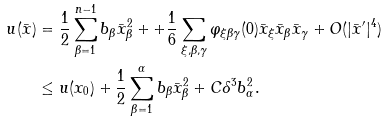Convert formula to latex. <formula><loc_0><loc_0><loc_500><loc_500>u ( \bar { x } ) & = \frac { 1 } { 2 } \sum _ { \beta = 1 } ^ { n - 1 } b _ { \beta } \bar { x } _ { \beta } ^ { 2 } + + \frac { 1 } { 6 } \sum _ { \xi , \beta , \gamma } \varphi _ { \xi \beta \gamma } ( 0 ) \bar { x } _ { \xi } \bar { x } _ { \beta } \bar { x } _ { \gamma } + O ( | \bar { x } ^ { \prime } | ^ { 4 } ) \\ & \leq u ( x _ { 0 } ) + \frac { 1 } { 2 } \sum _ { \beta = 1 } ^ { \alpha } b _ { \beta } \bar { x } _ { \beta } ^ { 2 } + C \delta ^ { 3 } b _ { \alpha } ^ { 2 } .</formula> 